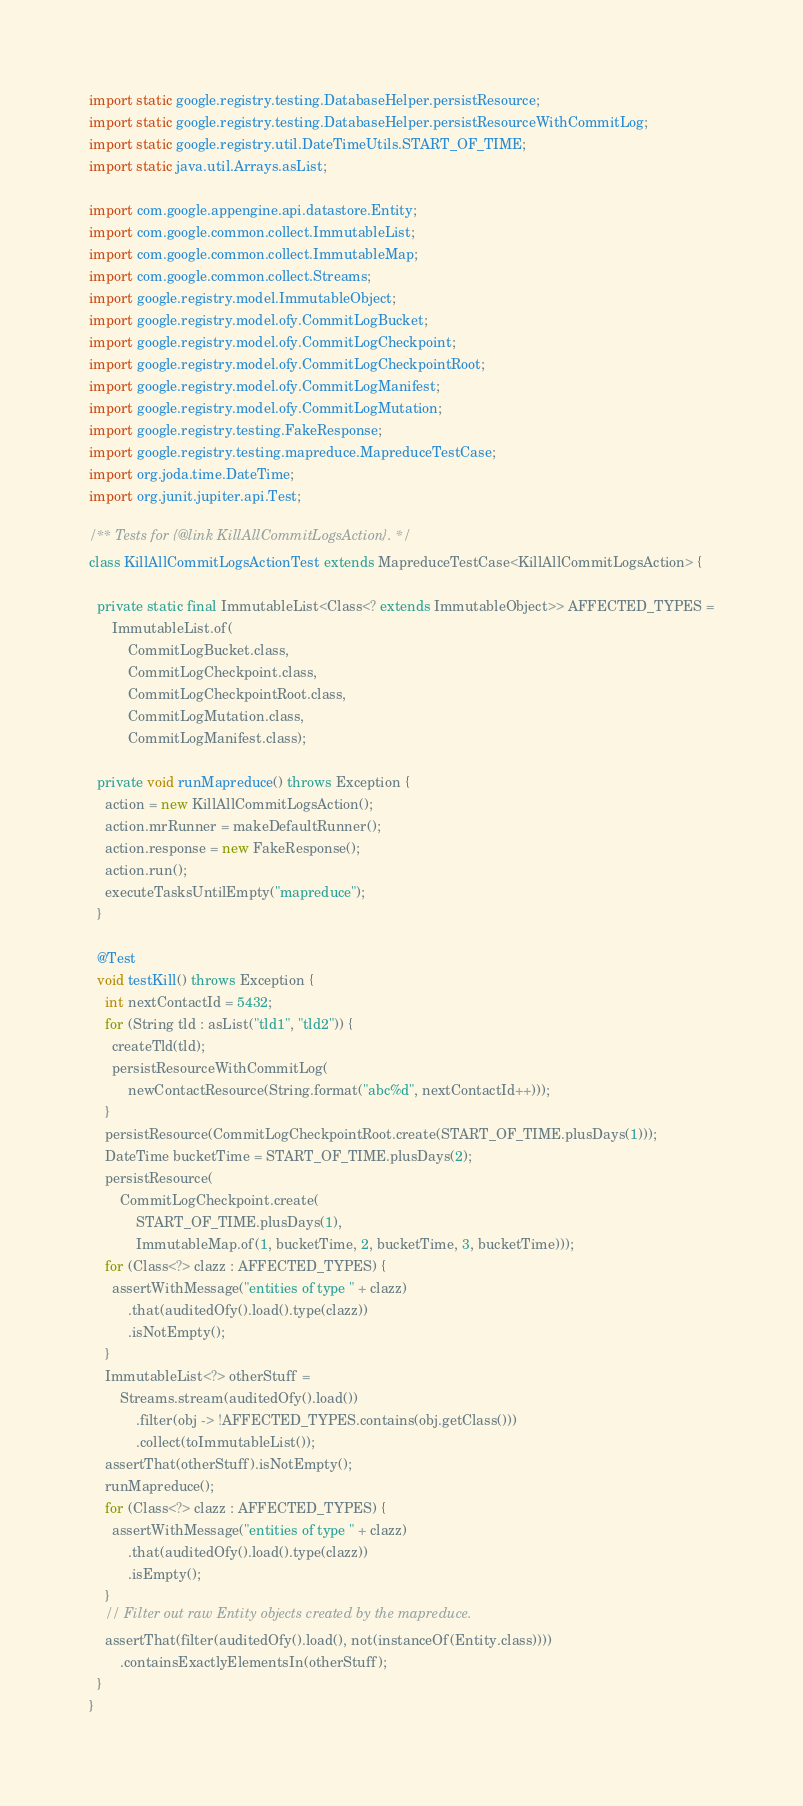<code> <loc_0><loc_0><loc_500><loc_500><_Java_>import static google.registry.testing.DatabaseHelper.persistResource;
import static google.registry.testing.DatabaseHelper.persistResourceWithCommitLog;
import static google.registry.util.DateTimeUtils.START_OF_TIME;
import static java.util.Arrays.asList;

import com.google.appengine.api.datastore.Entity;
import com.google.common.collect.ImmutableList;
import com.google.common.collect.ImmutableMap;
import com.google.common.collect.Streams;
import google.registry.model.ImmutableObject;
import google.registry.model.ofy.CommitLogBucket;
import google.registry.model.ofy.CommitLogCheckpoint;
import google.registry.model.ofy.CommitLogCheckpointRoot;
import google.registry.model.ofy.CommitLogManifest;
import google.registry.model.ofy.CommitLogMutation;
import google.registry.testing.FakeResponse;
import google.registry.testing.mapreduce.MapreduceTestCase;
import org.joda.time.DateTime;
import org.junit.jupiter.api.Test;

/** Tests for {@link KillAllCommitLogsAction}. */
class KillAllCommitLogsActionTest extends MapreduceTestCase<KillAllCommitLogsAction> {

  private static final ImmutableList<Class<? extends ImmutableObject>> AFFECTED_TYPES =
      ImmutableList.of(
          CommitLogBucket.class,
          CommitLogCheckpoint.class,
          CommitLogCheckpointRoot.class,
          CommitLogMutation.class,
          CommitLogManifest.class);

  private void runMapreduce() throws Exception {
    action = new KillAllCommitLogsAction();
    action.mrRunner = makeDefaultRunner();
    action.response = new FakeResponse();
    action.run();
    executeTasksUntilEmpty("mapreduce");
  }

  @Test
  void testKill() throws Exception {
    int nextContactId = 5432;
    for (String tld : asList("tld1", "tld2")) {
      createTld(tld);
      persistResourceWithCommitLog(
          newContactResource(String.format("abc%d", nextContactId++)));
    }
    persistResource(CommitLogCheckpointRoot.create(START_OF_TIME.plusDays(1)));
    DateTime bucketTime = START_OF_TIME.plusDays(2);
    persistResource(
        CommitLogCheckpoint.create(
            START_OF_TIME.plusDays(1),
            ImmutableMap.of(1, bucketTime, 2, bucketTime, 3, bucketTime)));
    for (Class<?> clazz : AFFECTED_TYPES) {
      assertWithMessage("entities of type " + clazz)
          .that(auditedOfy().load().type(clazz))
          .isNotEmpty();
    }
    ImmutableList<?> otherStuff =
        Streams.stream(auditedOfy().load())
            .filter(obj -> !AFFECTED_TYPES.contains(obj.getClass()))
            .collect(toImmutableList());
    assertThat(otherStuff).isNotEmpty();
    runMapreduce();
    for (Class<?> clazz : AFFECTED_TYPES) {
      assertWithMessage("entities of type " + clazz)
          .that(auditedOfy().load().type(clazz))
          .isEmpty();
    }
    // Filter out raw Entity objects created by the mapreduce.
    assertThat(filter(auditedOfy().load(), not(instanceOf(Entity.class))))
        .containsExactlyElementsIn(otherStuff);
  }
}
</code> 